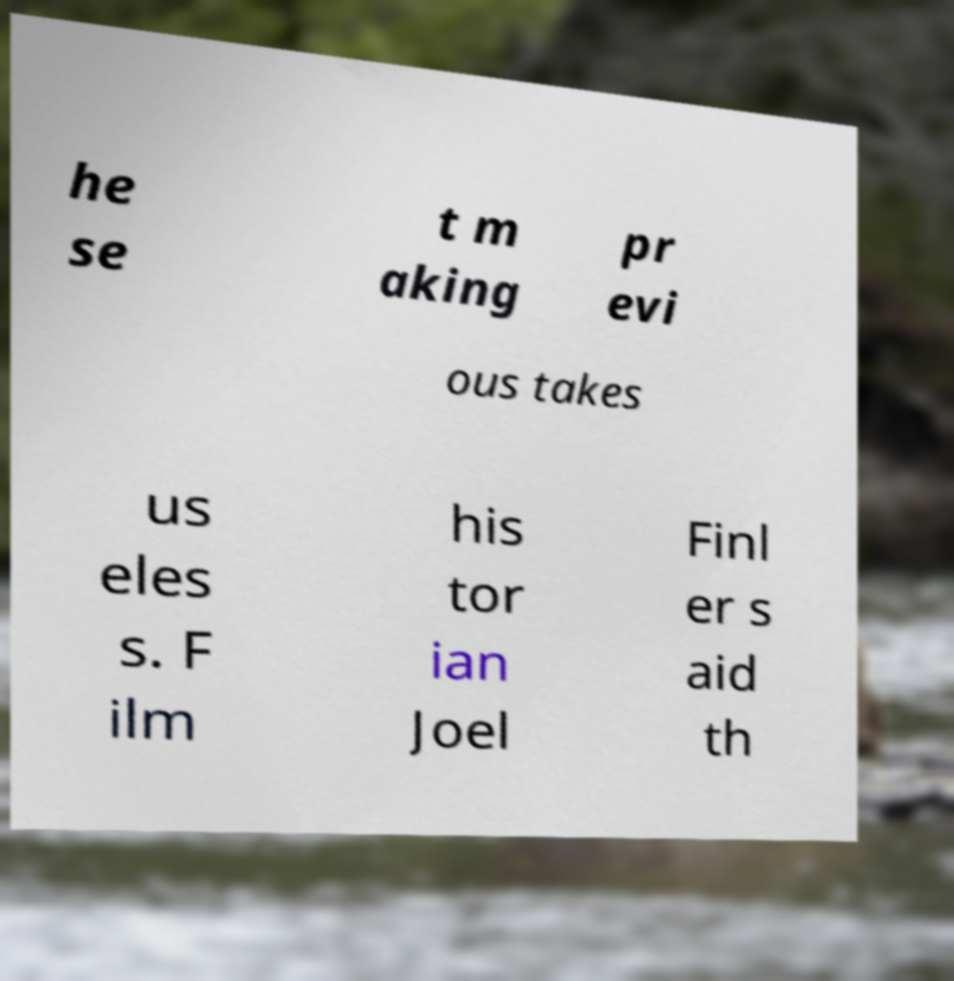I need the written content from this picture converted into text. Can you do that? he se t m aking pr evi ous takes us eles s. F ilm his tor ian Joel Finl er s aid th 